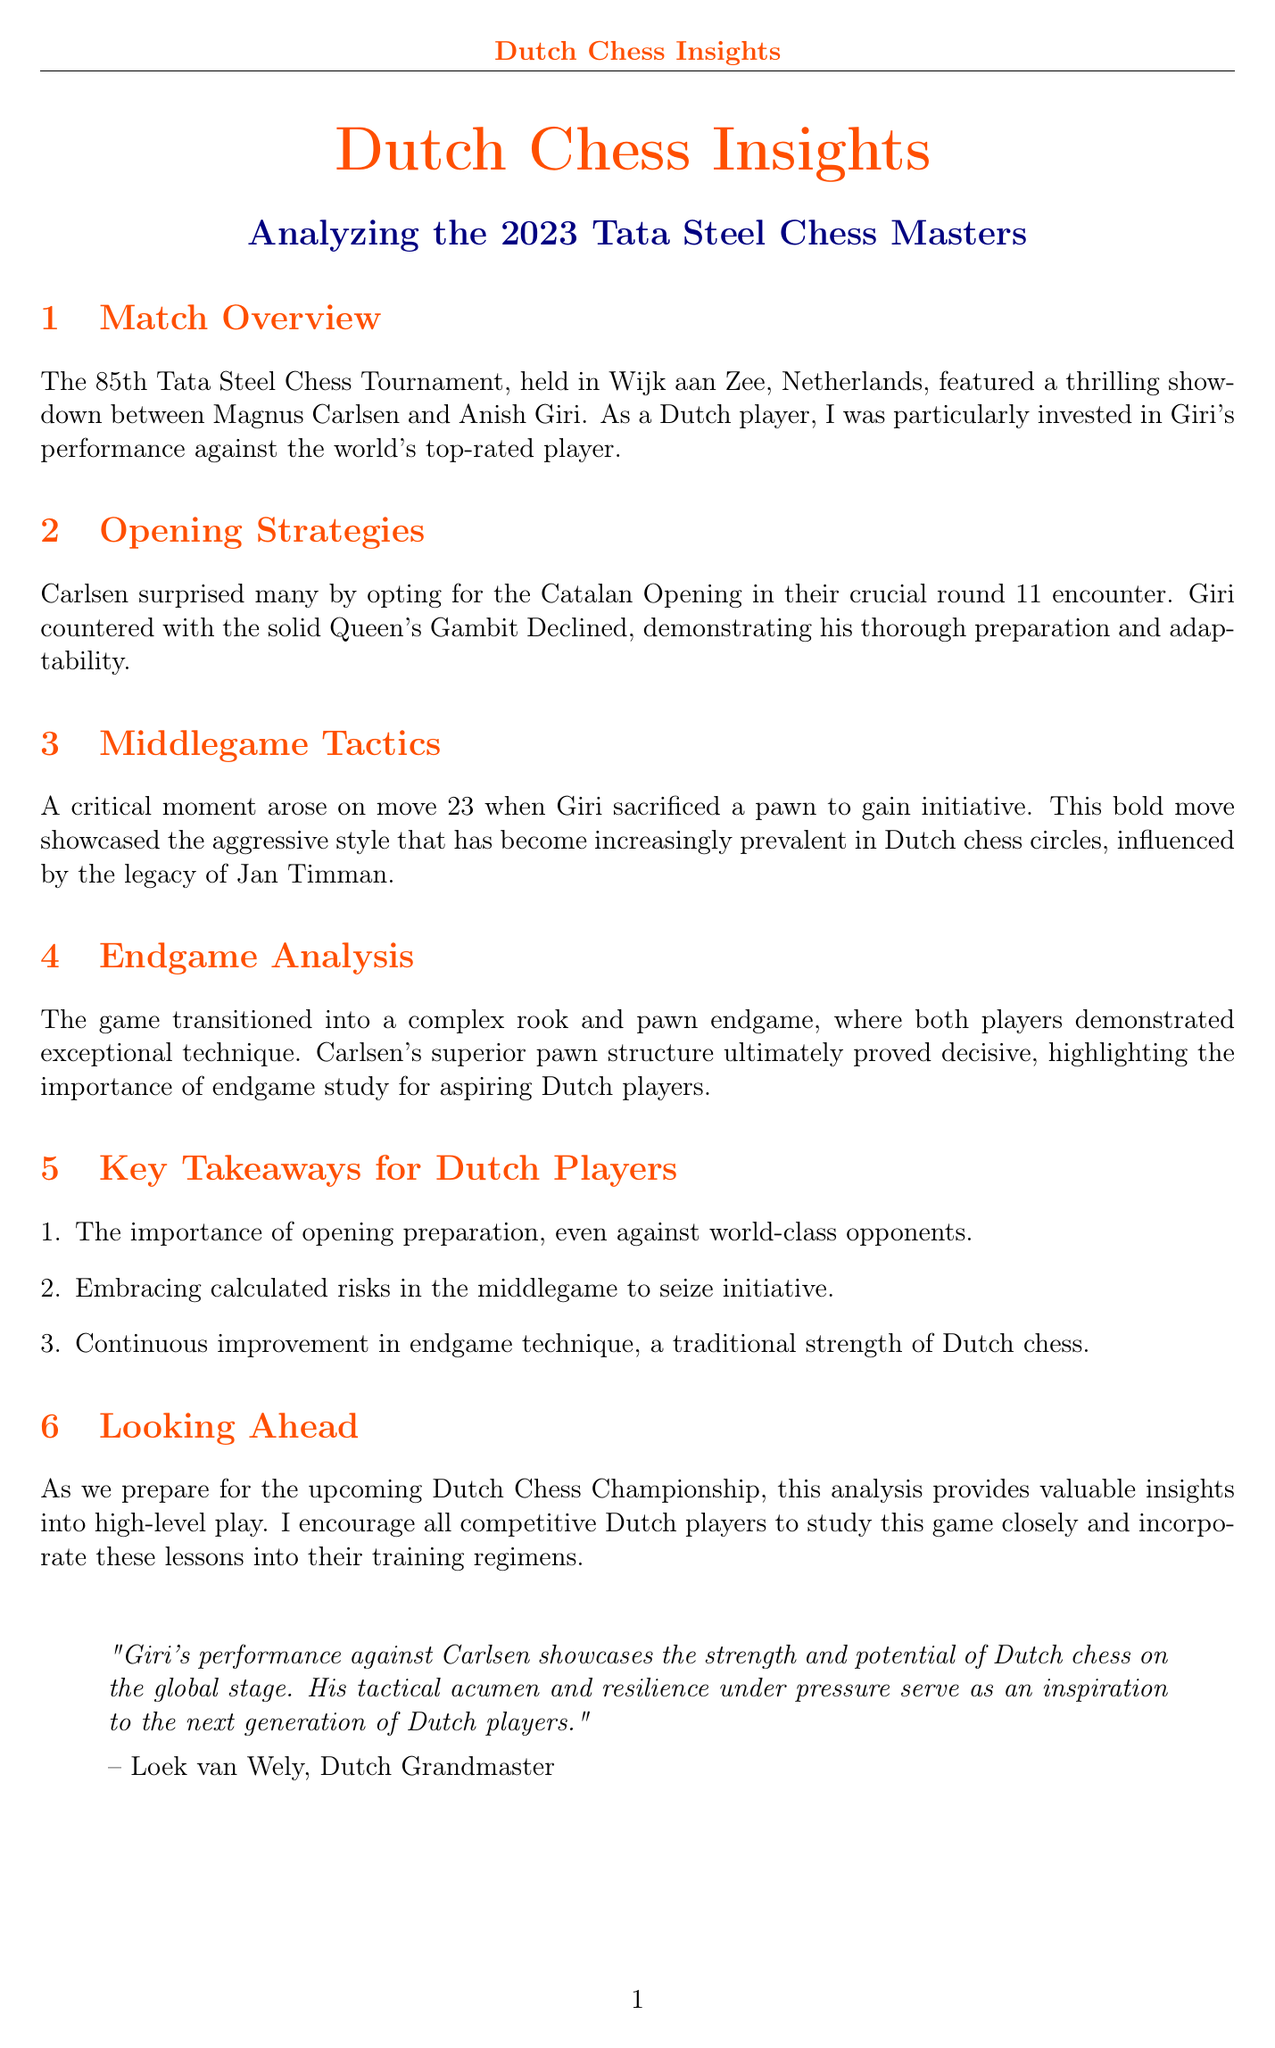What was the title of the newsletter? The title of the newsletter is clearly stated at the beginning of the document.
Answer: Dutch Chess Insights: Analyzing the 2023 Tata Steel Chess Masters Who played in the high-profile match discussed? The match overview section mentions the players involved in the encounter.
Answer: Magnus Carlsen and Anish Giri What opening did Carlsen choose in the match? The opening strategies section details Carlsen's choice of opening.
Answer: Catalan Opening On which move did Giri sacrifice a pawn? The middlegame tactics section specifies the move number of Giri's critical pawn sacrifice.
Answer: 23 What was the date of the Dutch Chess Championship? The upcoming events section provides the date for the championship.
Answer: July 1-9, 2023 Who provided the expert commentary? The expert commentary section names the contributor of the commentary.
Answer: Loek van Wely What is emphasized as a traditional strength of Dutch chess? The key takeaways enumerate various aspects of Dutch chess strengths, highlighting a specific area.
Answer: Endgame technique What are players encouraged to study for improvement? The training tip section advises on specific player games to analyze for improvement.
Answer: Recent games from top Dutch players 